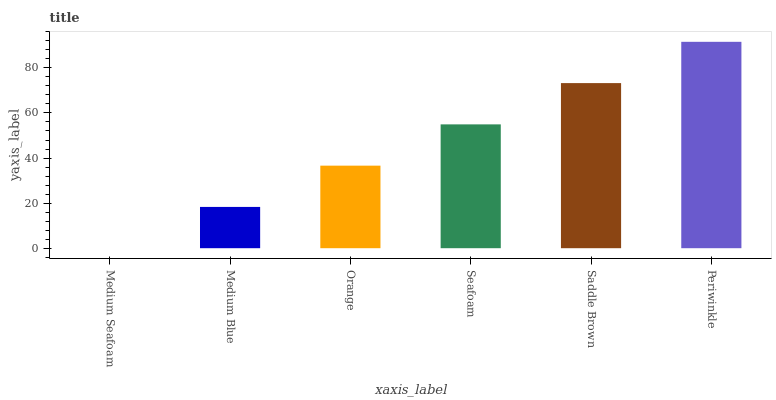Is Medium Blue the minimum?
Answer yes or no. No. Is Medium Blue the maximum?
Answer yes or no. No. Is Medium Blue greater than Medium Seafoam?
Answer yes or no. Yes. Is Medium Seafoam less than Medium Blue?
Answer yes or no. Yes. Is Medium Seafoam greater than Medium Blue?
Answer yes or no. No. Is Medium Blue less than Medium Seafoam?
Answer yes or no. No. Is Seafoam the high median?
Answer yes or no. Yes. Is Orange the low median?
Answer yes or no. Yes. Is Medium Blue the high median?
Answer yes or no. No. Is Periwinkle the low median?
Answer yes or no. No. 